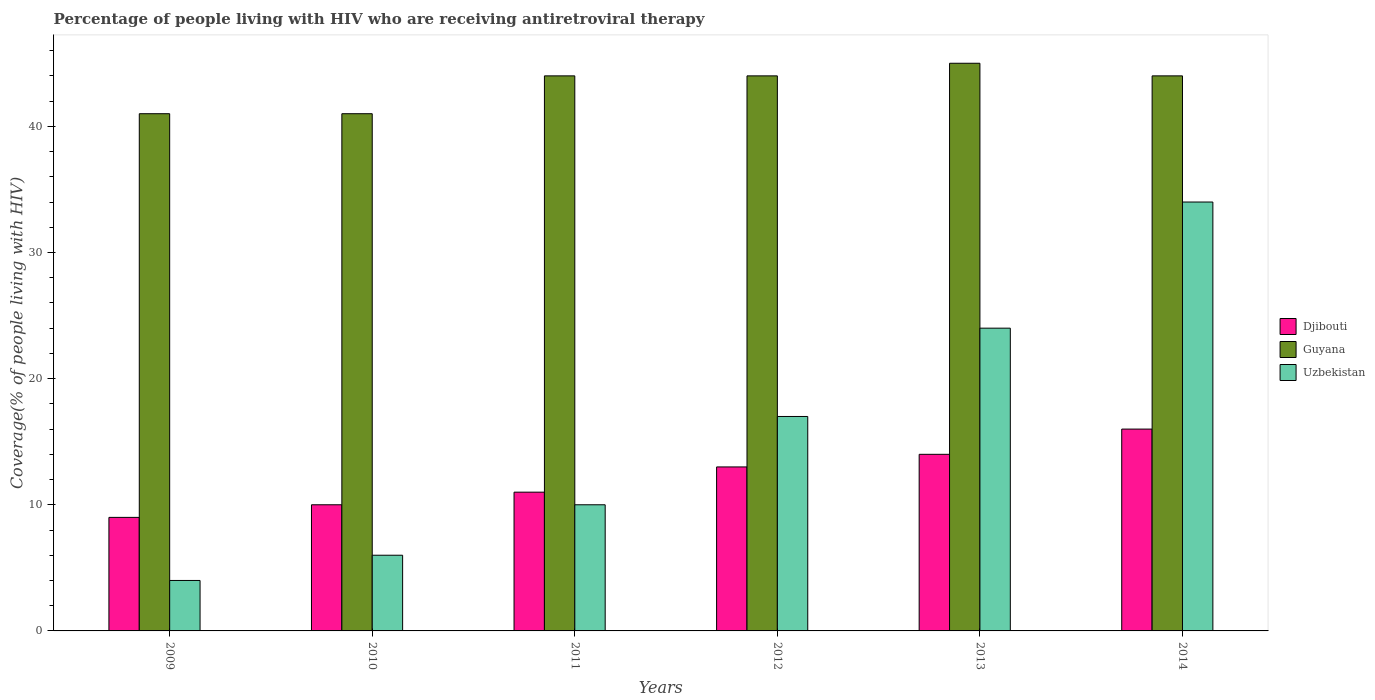How many different coloured bars are there?
Your answer should be compact. 3. How many groups of bars are there?
Make the answer very short. 6. Are the number of bars per tick equal to the number of legend labels?
Your answer should be compact. Yes. Are the number of bars on each tick of the X-axis equal?
Your answer should be very brief. Yes. How many bars are there on the 4th tick from the right?
Your answer should be very brief. 3. What is the label of the 6th group of bars from the left?
Offer a very short reply. 2014. In how many cases, is the number of bars for a given year not equal to the number of legend labels?
Keep it short and to the point. 0. What is the percentage of the HIV infected people who are receiving antiretroviral therapy in Djibouti in 2011?
Offer a very short reply. 11. Across all years, what is the maximum percentage of the HIV infected people who are receiving antiretroviral therapy in Djibouti?
Your answer should be very brief. 16. Across all years, what is the minimum percentage of the HIV infected people who are receiving antiretroviral therapy in Uzbekistan?
Give a very brief answer. 4. What is the total percentage of the HIV infected people who are receiving antiretroviral therapy in Guyana in the graph?
Make the answer very short. 259. What is the difference between the percentage of the HIV infected people who are receiving antiretroviral therapy in Guyana in 2013 and that in 2014?
Make the answer very short. 1. What is the difference between the percentage of the HIV infected people who are receiving antiretroviral therapy in Guyana in 2010 and the percentage of the HIV infected people who are receiving antiretroviral therapy in Djibouti in 2013?
Ensure brevity in your answer.  27. What is the average percentage of the HIV infected people who are receiving antiretroviral therapy in Uzbekistan per year?
Ensure brevity in your answer.  15.83. In the year 2014, what is the difference between the percentage of the HIV infected people who are receiving antiretroviral therapy in Uzbekistan and percentage of the HIV infected people who are receiving antiretroviral therapy in Djibouti?
Make the answer very short. 18. In how many years, is the percentage of the HIV infected people who are receiving antiretroviral therapy in Uzbekistan greater than 24 %?
Keep it short and to the point. 1. What is the ratio of the percentage of the HIV infected people who are receiving antiretroviral therapy in Guyana in 2009 to that in 2013?
Give a very brief answer. 0.91. What is the difference between the highest and the second highest percentage of the HIV infected people who are receiving antiretroviral therapy in Guyana?
Your answer should be compact. 1. What is the difference between the highest and the lowest percentage of the HIV infected people who are receiving antiretroviral therapy in Guyana?
Make the answer very short. 4. In how many years, is the percentage of the HIV infected people who are receiving antiretroviral therapy in Guyana greater than the average percentage of the HIV infected people who are receiving antiretroviral therapy in Guyana taken over all years?
Provide a short and direct response. 4. What does the 1st bar from the left in 2013 represents?
Provide a succinct answer. Djibouti. What does the 3rd bar from the right in 2012 represents?
Ensure brevity in your answer.  Djibouti. Are all the bars in the graph horizontal?
Make the answer very short. No. What is the difference between two consecutive major ticks on the Y-axis?
Offer a terse response. 10. Are the values on the major ticks of Y-axis written in scientific E-notation?
Your answer should be compact. No. Does the graph contain any zero values?
Your answer should be compact. No. Does the graph contain grids?
Your answer should be compact. No. How are the legend labels stacked?
Ensure brevity in your answer.  Vertical. What is the title of the graph?
Provide a succinct answer. Percentage of people living with HIV who are receiving antiretroviral therapy. Does "Qatar" appear as one of the legend labels in the graph?
Make the answer very short. No. What is the label or title of the X-axis?
Provide a succinct answer. Years. What is the label or title of the Y-axis?
Provide a succinct answer. Coverage(% of people living with HIV). What is the Coverage(% of people living with HIV) in Guyana in 2009?
Offer a terse response. 41. What is the Coverage(% of people living with HIV) in Djibouti in 2010?
Give a very brief answer. 10. What is the Coverage(% of people living with HIV) in Uzbekistan in 2011?
Ensure brevity in your answer.  10. What is the Coverage(% of people living with HIV) in Djibouti in 2012?
Ensure brevity in your answer.  13. What is the Coverage(% of people living with HIV) of Uzbekistan in 2013?
Your response must be concise. 24. What is the Coverage(% of people living with HIV) of Djibouti in 2014?
Offer a terse response. 16. What is the Coverage(% of people living with HIV) in Guyana in 2014?
Make the answer very short. 44. What is the Coverage(% of people living with HIV) in Uzbekistan in 2014?
Provide a short and direct response. 34. Across all years, what is the maximum Coverage(% of people living with HIV) in Djibouti?
Your answer should be compact. 16. Across all years, what is the maximum Coverage(% of people living with HIV) of Guyana?
Offer a terse response. 45. What is the total Coverage(% of people living with HIV) of Djibouti in the graph?
Ensure brevity in your answer.  73. What is the total Coverage(% of people living with HIV) of Guyana in the graph?
Provide a succinct answer. 259. What is the total Coverage(% of people living with HIV) in Uzbekistan in the graph?
Your answer should be very brief. 95. What is the difference between the Coverage(% of people living with HIV) in Djibouti in 2009 and that in 2010?
Give a very brief answer. -1. What is the difference between the Coverage(% of people living with HIV) of Guyana in 2009 and that in 2010?
Give a very brief answer. 0. What is the difference between the Coverage(% of people living with HIV) of Uzbekistan in 2009 and that in 2010?
Offer a very short reply. -2. What is the difference between the Coverage(% of people living with HIV) in Djibouti in 2009 and that in 2011?
Provide a succinct answer. -2. What is the difference between the Coverage(% of people living with HIV) of Guyana in 2009 and that in 2011?
Provide a short and direct response. -3. What is the difference between the Coverage(% of people living with HIV) of Uzbekistan in 2009 and that in 2011?
Offer a very short reply. -6. What is the difference between the Coverage(% of people living with HIV) in Djibouti in 2009 and that in 2012?
Your answer should be compact. -4. What is the difference between the Coverage(% of people living with HIV) of Uzbekistan in 2009 and that in 2012?
Your answer should be compact. -13. What is the difference between the Coverage(% of people living with HIV) of Guyana in 2009 and that in 2013?
Ensure brevity in your answer.  -4. What is the difference between the Coverage(% of people living with HIV) in Guyana in 2009 and that in 2014?
Keep it short and to the point. -3. What is the difference between the Coverage(% of people living with HIV) in Uzbekistan in 2009 and that in 2014?
Make the answer very short. -30. What is the difference between the Coverage(% of people living with HIV) of Uzbekistan in 2010 and that in 2011?
Make the answer very short. -4. What is the difference between the Coverage(% of people living with HIV) of Djibouti in 2010 and that in 2012?
Your response must be concise. -3. What is the difference between the Coverage(% of people living with HIV) of Djibouti in 2010 and that in 2013?
Provide a short and direct response. -4. What is the difference between the Coverage(% of people living with HIV) of Guyana in 2010 and that in 2013?
Make the answer very short. -4. What is the difference between the Coverage(% of people living with HIV) of Uzbekistan in 2010 and that in 2013?
Keep it short and to the point. -18. What is the difference between the Coverage(% of people living with HIV) in Djibouti in 2010 and that in 2014?
Provide a short and direct response. -6. What is the difference between the Coverage(% of people living with HIV) in Djibouti in 2011 and that in 2012?
Make the answer very short. -2. What is the difference between the Coverage(% of people living with HIV) in Uzbekistan in 2011 and that in 2012?
Your answer should be very brief. -7. What is the difference between the Coverage(% of people living with HIV) of Uzbekistan in 2011 and that in 2014?
Give a very brief answer. -24. What is the difference between the Coverage(% of people living with HIV) of Djibouti in 2012 and that in 2013?
Make the answer very short. -1. What is the difference between the Coverage(% of people living with HIV) in Uzbekistan in 2012 and that in 2013?
Ensure brevity in your answer.  -7. What is the difference between the Coverage(% of people living with HIV) of Uzbekistan in 2012 and that in 2014?
Give a very brief answer. -17. What is the difference between the Coverage(% of people living with HIV) of Guyana in 2013 and that in 2014?
Make the answer very short. 1. What is the difference between the Coverage(% of people living with HIV) in Uzbekistan in 2013 and that in 2014?
Your answer should be very brief. -10. What is the difference between the Coverage(% of people living with HIV) in Djibouti in 2009 and the Coverage(% of people living with HIV) in Guyana in 2010?
Ensure brevity in your answer.  -32. What is the difference between the Coverage(% of people living with HIV) in Djibouti in 2009 and the Coverage(% of people living with HIV) in Uzbekistan in 2010?
Your response must be concise. 3. What is the difference between the Coverage(% of people living with HIV) of Djibouti in 2009 and the Coverage(% of people living with HIV) of Guyana in 2011?
Provide a short and direct response. -35. What is the difference between the Coverage(% of people living with HIV) of Djibouti in 2009 and the Coverage(% of people living with HIV) of Uzbekistan in 2011?
Provide a succinct answer. -1. What is the difference between the Coverage(% of people living with HIV) in Djibouti in 2009 and the Coverage(% of people living with HIV) in Guyana in 2012?
Your answer should be very brief. -35. What is the difference between the Coverage(% of people living with HIV) of Djibouti in 2009 and the Coverage(% of people living with HIV) of Guyana in 2013?
Offer a very short reply. -36. What is the difference between the Coverage(% of people living with HIV) in Djibouti in 2009 and the Coverage(% of people living with HIV) in Uzbekistan in 2013?
Ensure brevity in your answer.  -15. What is the difference between the Coverage(% of people living with HIV) of Guyana in 2009 and the Coverage(% of people living with HIV) of Uzbekistan in 2013?
Keep it short and to the point. 17. What is the difference between the Coverage(% of people living with HIV) of Djibouti in 2009 and the Coverage(% of people living with HIV) of Guyana in 2014?
Provide a short and direct response. -35. What is the difference between the Coverage(% of people living with HIV) in Djibouti in 2010 and the Coverage(% of people living with HIV) in Guyana in 2011?
Offer a very short reply. -34. What is the difference between the Coverage(% of people living with HIV) in Djibouti in 2010 and the Coverage(% of people living with HIV) in Uzbekistan in 2011?
Offer a terse response. 0. What is the difference between the Coverage(% of people living with HIV) of Guyana in 2010 and the Coverage(% of people living with HIV) of Uzbekistan in 2011?
Make the answer very short. 31. What is the difference between the Coverage(% of people living with HIV) in Djibouti in 2010 and the Coverage(% of people living with HIV) in Guyana in 2012?
Make the answer very short. -34. What is the difference between the Coverage(% of people living with HIV) in Guyana in 2010 and the Coverage(% of people living with HIV) in Uzbekistan in 2012?
Provide a short and direct response. 24. What is the difference between the Coverage(% of people living with HIV) in Djibouti in 2010 and the Coverage(% of people living with HIV) in Guyana in 2013?
Give a very brief answer. -35. What is the difference between the Coverage(% of people living with HIV) of Djibouti in 2010 and the Coverage(% of people living with HIV) of Guyana in 2014?
Your response must be concise. -34. What is the difference between the Coverage(% of people living with HIV) of Djibouti in 2010 and the Coverage(% of people living with HIV) of Uzbekistan in 2014?
Keep it short and to the point. -24. What is the difference between the Coverage(% of people living with HIV) in Djibouti in 2011 and the Coverage(% of people living with HIV) in Guyana in 2012?
Provide a short and direct response. -33. What is the difference between the Coverage(% of people living with HIV) in Djibouti in 2011 and the Coverage(% of people living with HIV) in Uzbekistan in 2012?
Provide a short and direct response. -6. What is the difference between the Coverage(% of people living with HIV) in Guyana in 2011 and the Coverage(% of people living with HIV) in Uzbekistan in 2012?
Offer a very short reply. 27. What is the difference between the Coverage(% of people living with HIV) of Djibouti in 2011 and the Coverage(% of people living with HIV) of Guyana in 2013?
Offer a terse response. -34. What is the difference between the Coverage(% of people living with HIV) in Djibouti in 2011 and the Coverage(% of people living with HIV) in Guyana in 2014?
Make the answer very short. -33. What is the difference between the Coverage(% of people living with HIV) of Djibouti in 2011 and the Coverage(% of people living with HIV) of Uzbekistan in 2014?
Make the answer very short. -23. What is the difference between the Coverage(% of people living with HIV) of Guyana in 2011 and the Coverage(% of people living with HIV) of Uzbekistan in 2014?
Your response must be concise. 10. What is the difference between the Coverage(% of people living with HIV) of Djibouti in 2012 and the Coverage(% of people living with HIV) of Guyana in 2013?
Ensure brevity in your answer.  -32. What is the difference between the Coverage(% of people living with HIV) in Djibouti in 2012 and the Coverage(% of people living with HIV) in Uzbekistan in 2013?
Ensure brevity in your answer.  -11. What is the difference between the Coverage(% of people living with HIV) of Guyana in 2012 and the Coverage(% of people living with HIV) of Uzbekistan in 2013?
Your response must be concise. 20. What is the difference between the Coverage(% of people living with HIV) of Djibouti in 2012 and the Coverage(% of people living with HIV) of Guyana in 2014?
Your answer should be very brief. -31. What is the difference between the Coverage(% of people living with HIV) of Guyana in 2012 and the Coverage(% of people living with HIV) of Uzbekistan in 2014?
Your response must be concise. 10. What is the difference between the Coverage(% of people living with HIV) in Djibouti in 2013 and the Coverage(% of people living with HIV) in Uzbekistan in 2014?
Keep it short and to the point. -20. What is the average Coverage(% of people living with HIV) of Djibouti per year?
Keep it short and to the point. 12.17. What is the average Coverage(% of people living with HIV) of Guyana per year?
Ensure brevity in your answer.  43.17. What is the average Coverage(% of people living with HIV) of Uzbekistan per year?
Your answer should be very brief. 15.83. In the year 2009, what is the difference between the Coverage(% of people living with HIV) of Djibouti and Coverage(% of people living with HIV) of Guyana?
Your answer should be compact. -32. In the year 2009, what is the difference between the Coverage(% of people living with HIV) in Djibouti and Coverage(% of people living with HIV) in Uzbekistan?
Your response must be concise. 5. In the year 2009, what is the difference between the Coverage(% of people living with HIV) in Guyana and Coverage(% of people living with HIV) in Uzbekistan?
Your response must be concise. 37. In the year 2010, what is the difference between the Coverage(% of people living with HIV) in Djibouti and Coverage(% of people living with HIV) in Guyana?
Your response must be concise. -31. In the year 2010, what is the difference between the Coverage(% of people living with HIV) in Djibouti and Coverage(% of people living with HIV) in Uzbekistan?
Provide a short and direct response. 4. In the year 2011, what is the difference between the Coverage(% of people living with HIV) in Djibouti and Coverage(% of people living with HIV) in Guyana?
Your answer should be compact. -33. In the year 2012, what is the difference between the Coverage(% of people living with HIV) in Djibouti and Coverage(% of people living with HIV) in Guyana?
Provide a short and direct response. -31. In the year 2012, what is the difference between the Coverage(% of people living with HIV) of Guyana and Coverage(% of people living with HIV) of Uzbekistan?
Give a very brief answer. 27. In the year 2013, what is the difference between the Coverage(% of people living with HIV) in Djibouti and Coverage(% of people living with HIV) in Guyana?
Ensure brevity in your answer.  -31. In the year 2013, what is the difference between the Coverage(% of people living with HIV) of Guyana and Coverage(% of people living with HIV) of Uzbekistan?
Provide a succinct answer. 21. In the year 2014, what is the difference between the Coverage(% of people living with HIV) of Djibouti and Coverage(% of people living with HIV) of Guyana?
Give a very brief answer. -28. In the year 2014, what is the difference between the Coverage(% of people living with HIV) in Guyana and Coverage(% of people living with HIV) in Uzbekistan?
Provide a succinct answer. 10. What is the ratio of the Coverage(% of people living with HIV) of Djibouti in 2009 to that in 2010?
Give a very brief answer. 0.9. What is the ratio of the Coverage(% of people living with HIV) in Uzbekistan in 2009 to that in 2010?
Your answer should be very brief. 0.67. What is the ratio of the Coverage(% of people living with HIV) in Djibouti in 2009 to that in 2011?
Provide a succinct answer. 0.82. What is the ratio of the Coverage(% of people living with HIV) in Guyana in 2009 to that in 2011?
Keep it short and to the point. 0.93. What is the ratio of the Coverage(% of people living with HIV) in Uzbekistan in 2009 to that in 2011?
Ensure brevity in your answer.  0.4. What is the ratio of the Coverage(% of people living with HIV) of Djibouti in 2009 to that in 2012?
Provide a succinct answer. 0.69. What is the ratio of the Coverage(% of people living with HIV) in Guyana in 2009 to that in 2012?
Offer a very short reply. 0.93. What is the ratio of the Coverage(% of people living with HIV) in Uzbekistan in 2009 to that in 2012?
Give a very brief answer. 0.24. What is the ratio of the Coverage(% of people living with HIV) of Djibouti in 2009 to that in 2013?
Your answer should be compact. 0.64. What is the ratio of the Coverage(% of people living with HIV) of Guyana in 2009 to that in 2013?
Make the answer very short. 0.91. What is the ratio of the Coverage(% of people living with HIV) of Djibouti in 2009 to that in 2014?
Offer a terse response. 0.56. What is the ratio of the Coverage(% of people living with HIV) in Guyana in 2009 to that in 2014?
Give a very brief answer. 0.93. What is the ratio of the Coverage(% of people living with HIV) of Uzbekistan in 2009 to that in 2014?
Offer a very short reply. 0.12. What is the ratio of the Coverage(% of people living with HIV) of Djibouti in 2010 to that in 2011?
Keep it short and to the point. 0.91. What is the ratio of the Coverage(% of people living with HIV) of Guyana in 2010 to that in 2011?
Offer a very short reply. 0.93. What is the ratio of the Coverage(% of people living with HIV) in Djibouti in 2010 to that in 2012?
Ensure brevity in your answer.  0.77. What is the ratio of the Coverage(% of people living with HIV) of Guyana in 2010 to that in 2012?
Keep it short and to the point. 0.93. What is the ratio of the Coverage(% of people living with HIV) of Uzbekistan in 2010 to that in 2012?
Keep it short and to the point. 0.35. What is the ratio of the Coverage(% of people living with HIV) of Djibouti in 2010 to that in 2013?
Provide a short and direct response. 0.71. What is the ratio of the Coverage(% of people living with HIV) in Guyana in 2010 to that in 2013?
Your answer should be very brief. 0.91. What is the ratio of the Coverage(% of people living with HIV) in Uzbekistan in 2010 to that in 2013?
Provide a short and direct response. 0.25. What is the ratio of the Coverage(% of people living with HIV) of Djibouti in 2010 to that in 2014?
Give a very brief answer. 0.62. What is the ratio of the Coverage(% of people living with HIV) of Guyana in 2010 to that in 2014?
Provide a succinct answer. 0.93. What is the ratio of the Coverage(% of people living with HIV) in Uzbekistan in 2010 to that in 2014?
Your answer should be very brief. 0.18. What is the ratio of the Coverage(% of people living with HIV) of Djibouti in 2011 to that in 2012?
Your answer should be very brief. 0.85. What is the ratio of the Coverage(% of people living with HIV) of Guyana in 2011 to that in 2012?
Keep it short and to the point. 1. What is the ratio of the Coverage(% of people living with HIV) in Uzbekistan in 2011 to that in 2012?
Your answer should be very brief. 0.59. What is the ratio of the Coverage(% of people living with HIV) in Djibouti in 2011 to that in 2013?
Keep it short and to the point. 0.79. What is the ratio of the Coverage(% of people living with HIV) in Guyana in 2011 to that in 2013?
Ensure brevity in your answer.  0.98. What is the ratio of the Coverage(% of people living with HIV) in Uzbekistan in 2011 to that in 2013?
Keep it short and to the point. 0.42. What is the ratio of the Coverage(% of people living with HIV) of Djibouti in 2011 to that in 2014?
Offer a terse response. 0.69. What is the ratio of the Coverage(% of people living with HIV) in Guyana in 2011 to that in 2014?
Make the answer very short. 1. What is the ratio of the Coverage(% of people living with HIV) in Uzbekistan in 2011 to that in 2014?
Your response must be concise. 0.29. What is the ratio of the Coverage(% of people living with HIV) of Guyana in 2012 to that in 2013?
Offer a terse response. 0.98. What is the ratio of the Coverage(% of people living with HIV) in Uzbekistan in 2012 to that in 2013?
Make the answer very short. 0.71. What is the ratio of the Coverage(% of people living with HIV) of Djibouti in 2012 to that in 2014?
Provide a succinct answer. 0.81. What is the ratio of the Coverage(% of people living with HIV) in Guyana in 2012 to that in 2014?
Ensure brevity in your answer.  1. What is the ratio of the Coverage(% of people living with HIV) in Uzbekistan in 2012 to that in 2014?
Keep it short and to the point. 0.5. What is the ratio of the Coverage(% of people living with HIV) in Guyana in 2013 to that in 2014?
Ensure brevity in your answer.  1.02. What is the ratio of the Coverage(% of people living with HIV) of Uzbekistan in 2013 to that in 2014?
Keep it short and to the point. 0.71. What is the difference between the highest and the second highest Coverage(% of people living with HIV) of Djibouti?
Give a very brief answer. 2. What is the difference between the highest and the second highest Coverage(% of people living with HIV) in Guyana?
Your answer should be very brief. 1. What is the difference between the highest and the second highest Coverage(% of people living with HIV) in Uzbekistan?
Provide a short and direct response. 10. What is the difference between the highest and the lowest Coverage(% of people living with HIV) in Uzbekistan?
Give a very brief answer. 30. 